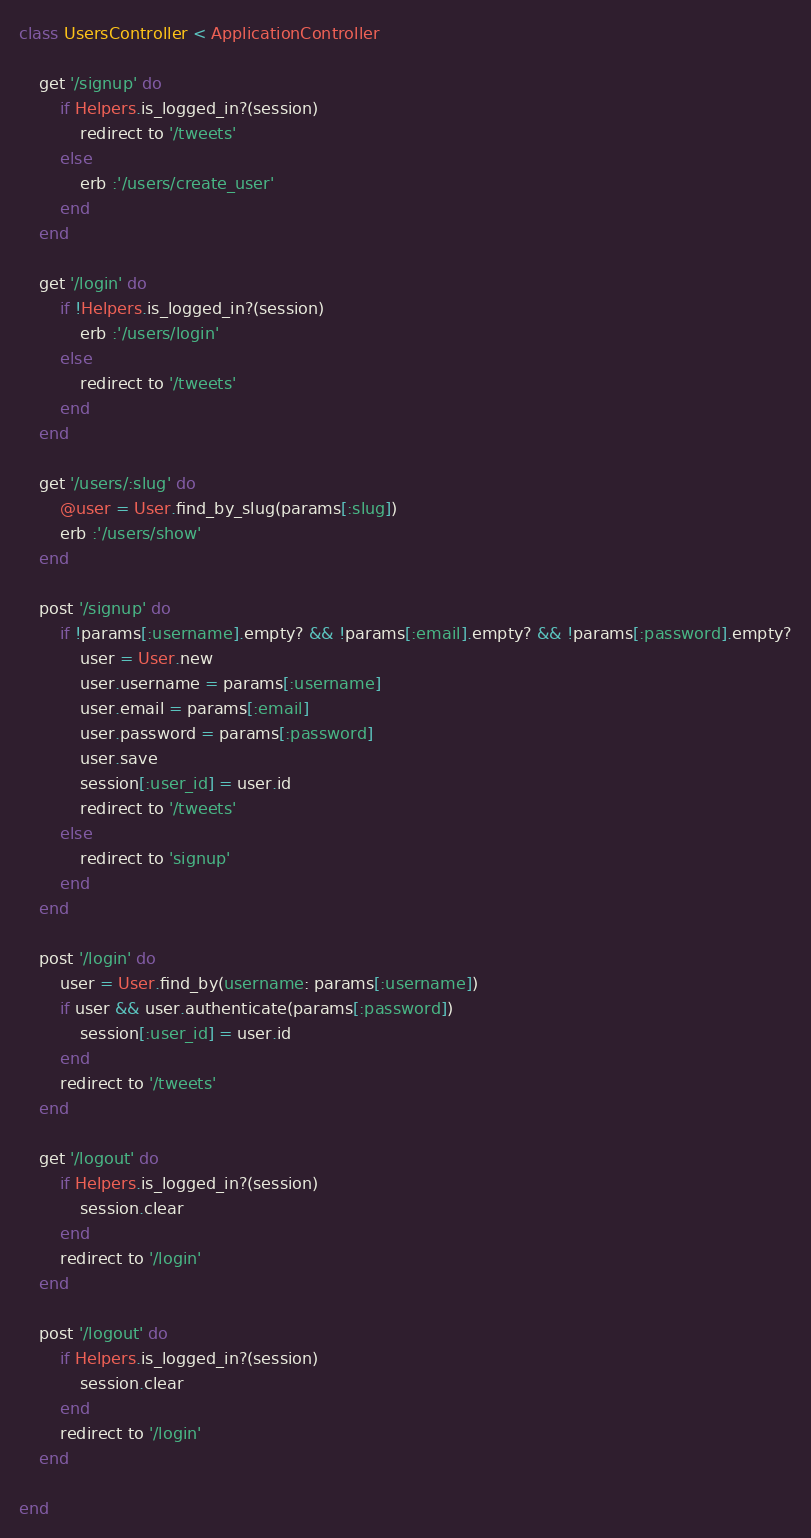<code> <loc_0><loc_0><loc_500><loc_500><_Ruby_>class UsersController < ApplicationController

    get '/signup' do
        if Helpers.is_logged_in?(session)
            redirect to '/tweets'
        else
            erb :'/users/create_user'
        end
    end

    get '/login' do
        if !Helpers.is_logged_in?(session)
            erb :'/users/login'
        else
            redirect to '/tweets'
        end
    end

    get '/users/:slug' do
        @user = User.find_by_slug(params[:slug])
        erb :'/users/show'
    end

    post '/signup' do
        if !params[:username].empty? && !params[:email].empty? && !params[:password].empty?
            user = User.new
            user.username = params[:username]
            user.email = params[:email]
            user.password = params[:password]
            user.save
            session[:user_id] = user.id
            redirect to '/tweets'
        else
            redirect to 'signup'
        end
    end

    post '/login' do
        user = User.find_by(username: params[:username])
        if user && user.authenticate(params[:password])
            session[:user_id] = user.id
        end
        redirect to '/tweets'
    end

    get '/logout' do
        if Helpers.is_logged_in?(session)
            session.clear
        end
        redirect to '/login'
    end

    post '/logout' do
        if Helpers.is_logged_in?(session)
            session.clear
        end
        redirect to '/login'
    end

end
</code> 